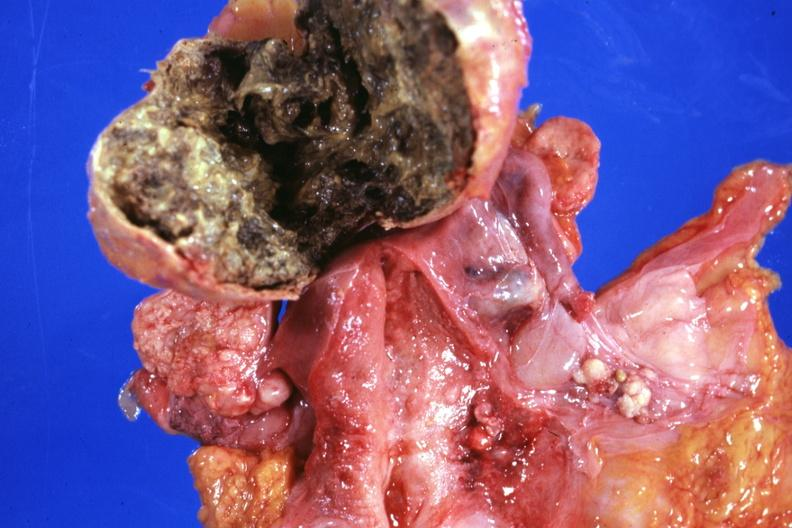s benign cystic teratoma present?
Answer the question using a single word or phrase. Yes 